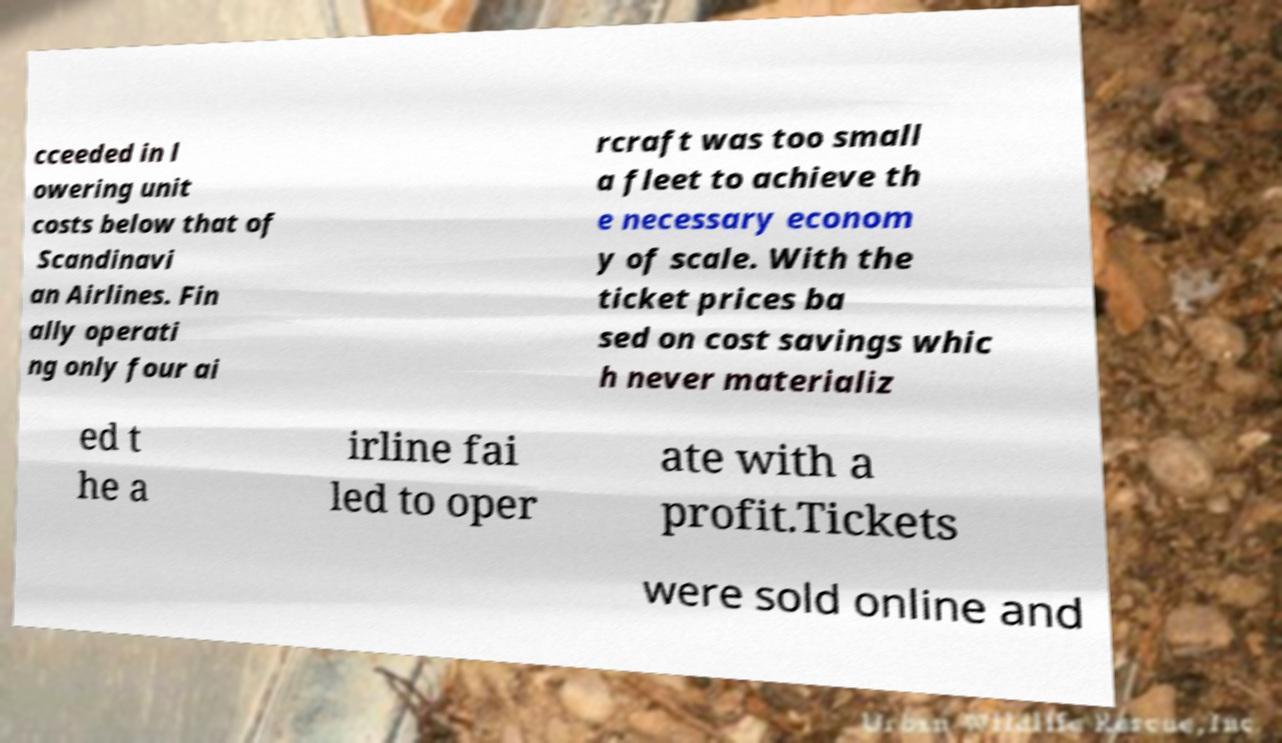Could you assist in decoding the text presented in this image and type it out clearly? cceeded in l owering unit costs below that of Scandinavi an Airlines. Fin ally operati ng only four ai rcraft was too small a fleet to achieve th e necessary econom y of scale. With the ticket prices ba sed on cost savings whic h never materializ ed t he a irline fai led to oper ate with a profit.Tickets were sold online and 